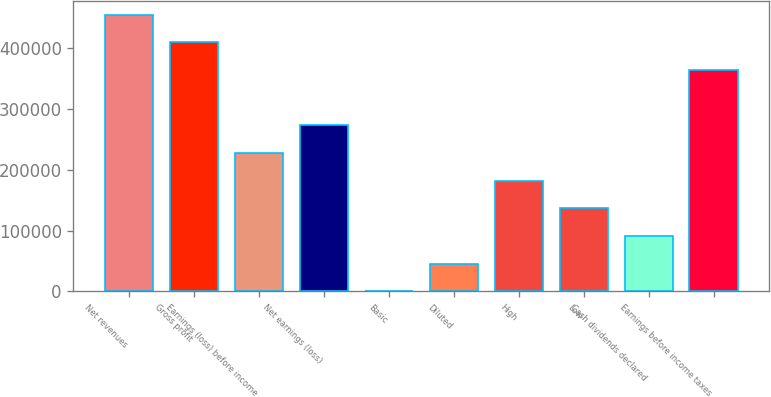Convert chart to OTSL. <chart><loc_0><loc_0><loc_500><loc_500><bar_chart><fcel>Net revenues<fcel>Gross profit<fcel>Earnings (loss) before income<fcel>Net earnings (loss)<fcel>Basic<fcel>Diluted<fcel>High<fcel>Low<fcel>Cash dividends declared<fcel>Earnings before income taxes<nl><fcel>454944<fcel>409450<fcel>227472<fcel>272966<fcel>0.02<fcel>45494.4<fcel>181978<fcel>136483<fcel>90988.8<fcel>363955<nl></chart> 